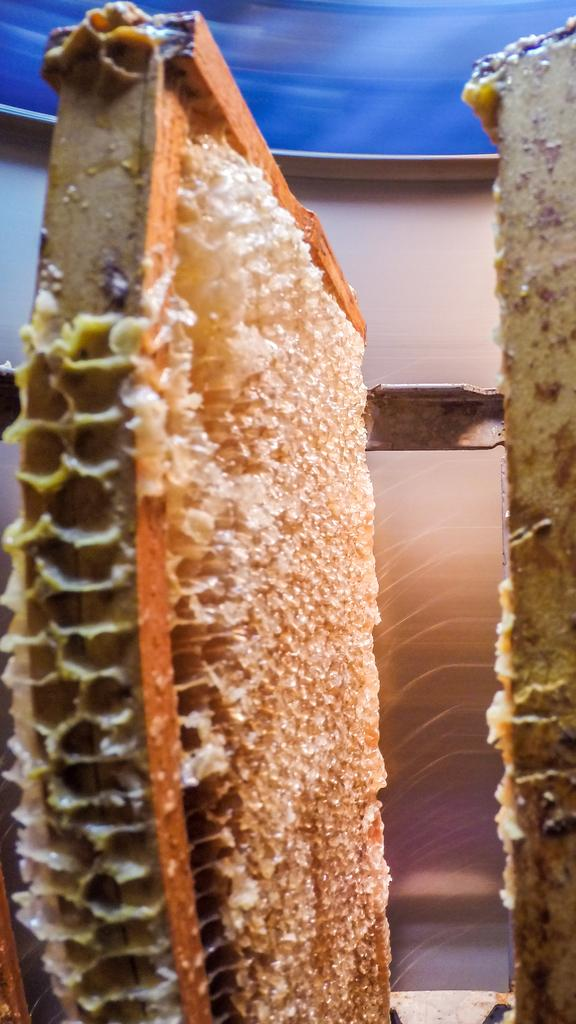What is the main subject of the image? The main subject of the image is a honey bee nest. Can you tell me what the stranger is doing in front of the judge in the image? There is no stranger or judge present in the image; it only features a honey bee nest. 